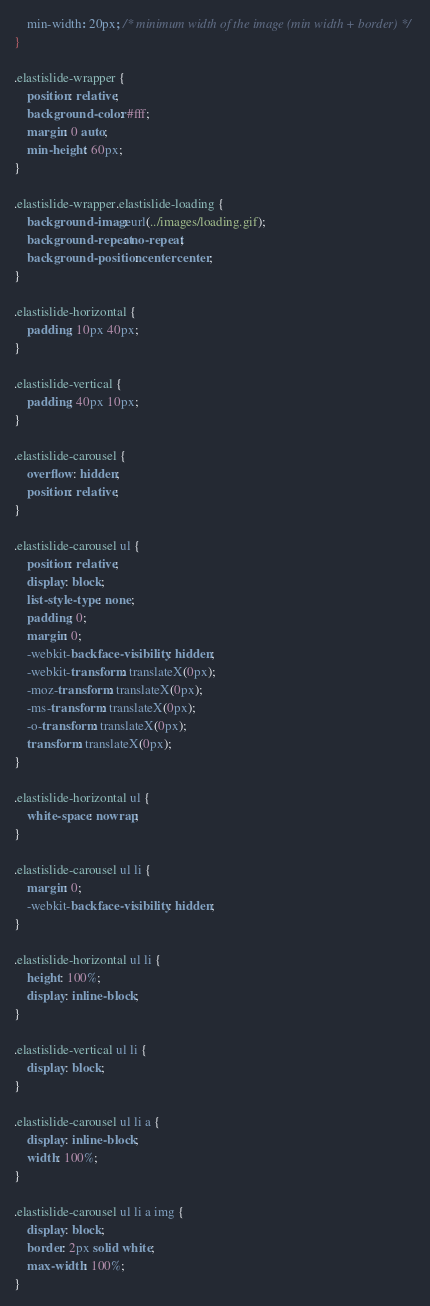<code> <loc_0><loc_0><loc_500><loc_500><_CSS_>	min-width: 20px; /* minimum width of the image (min width + border) */
}

.elastislide-wrapper {
	position: relative;
	background-color: #fff;
	margin: 0 auto;
	min-height: 60px;
}

.elastislide-wrapper.elastislide-loading {
	background-image: url(../images/loading.gif);
	background-repeat: no-repeat;
	background-position: center center;
}

.elastislide-horizontal {
	padding: 10px 40px;
}

.elastislide-vertical {
	padding: 40px 10px;
}

.elastislide-carousel {
	overflow: hidden;
	position: relative;
}

.elastislide-carousel ul {
	position: relative;
	display: block;
	list-style-type: none;
	padding: 0;
	margin: 0;
	-webkit-backface-visibility: hidden;
	-webkit-transform: translateX(0px);
	-moz-transform: translateX(0px);
	-ms-transform: translateX(0px);
	-o-transform: translateX(0px);
	transform: translateX(0px);
}

.elastislide-horizontal ul {
	white-space: nowrap;
}

.elastislide-carousel ul li {
	margin: 0;
	-webkit-backface-visibility: hidden;
}

.elastislide-horizontal ul li {
	height: 100%;
	display: inline-block;
}

.elastislide-vertical ul li {
	display: block;
}

.elastislide-carousel ul li a {
	display: inline-block;
	width: 100%;
}

.elastislide-carousel ul li a img {
	display: block;
	border: 2px solid white;
	max-width: 100%;
}
</code> 